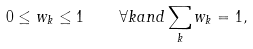<formula> <loc_0><loc_0><loc_500><loc_500>0 \leq w _ { k } \leq 1 \quad \forall k a n d \sum _ { k } w _ { k } = 1 ,</formula> 